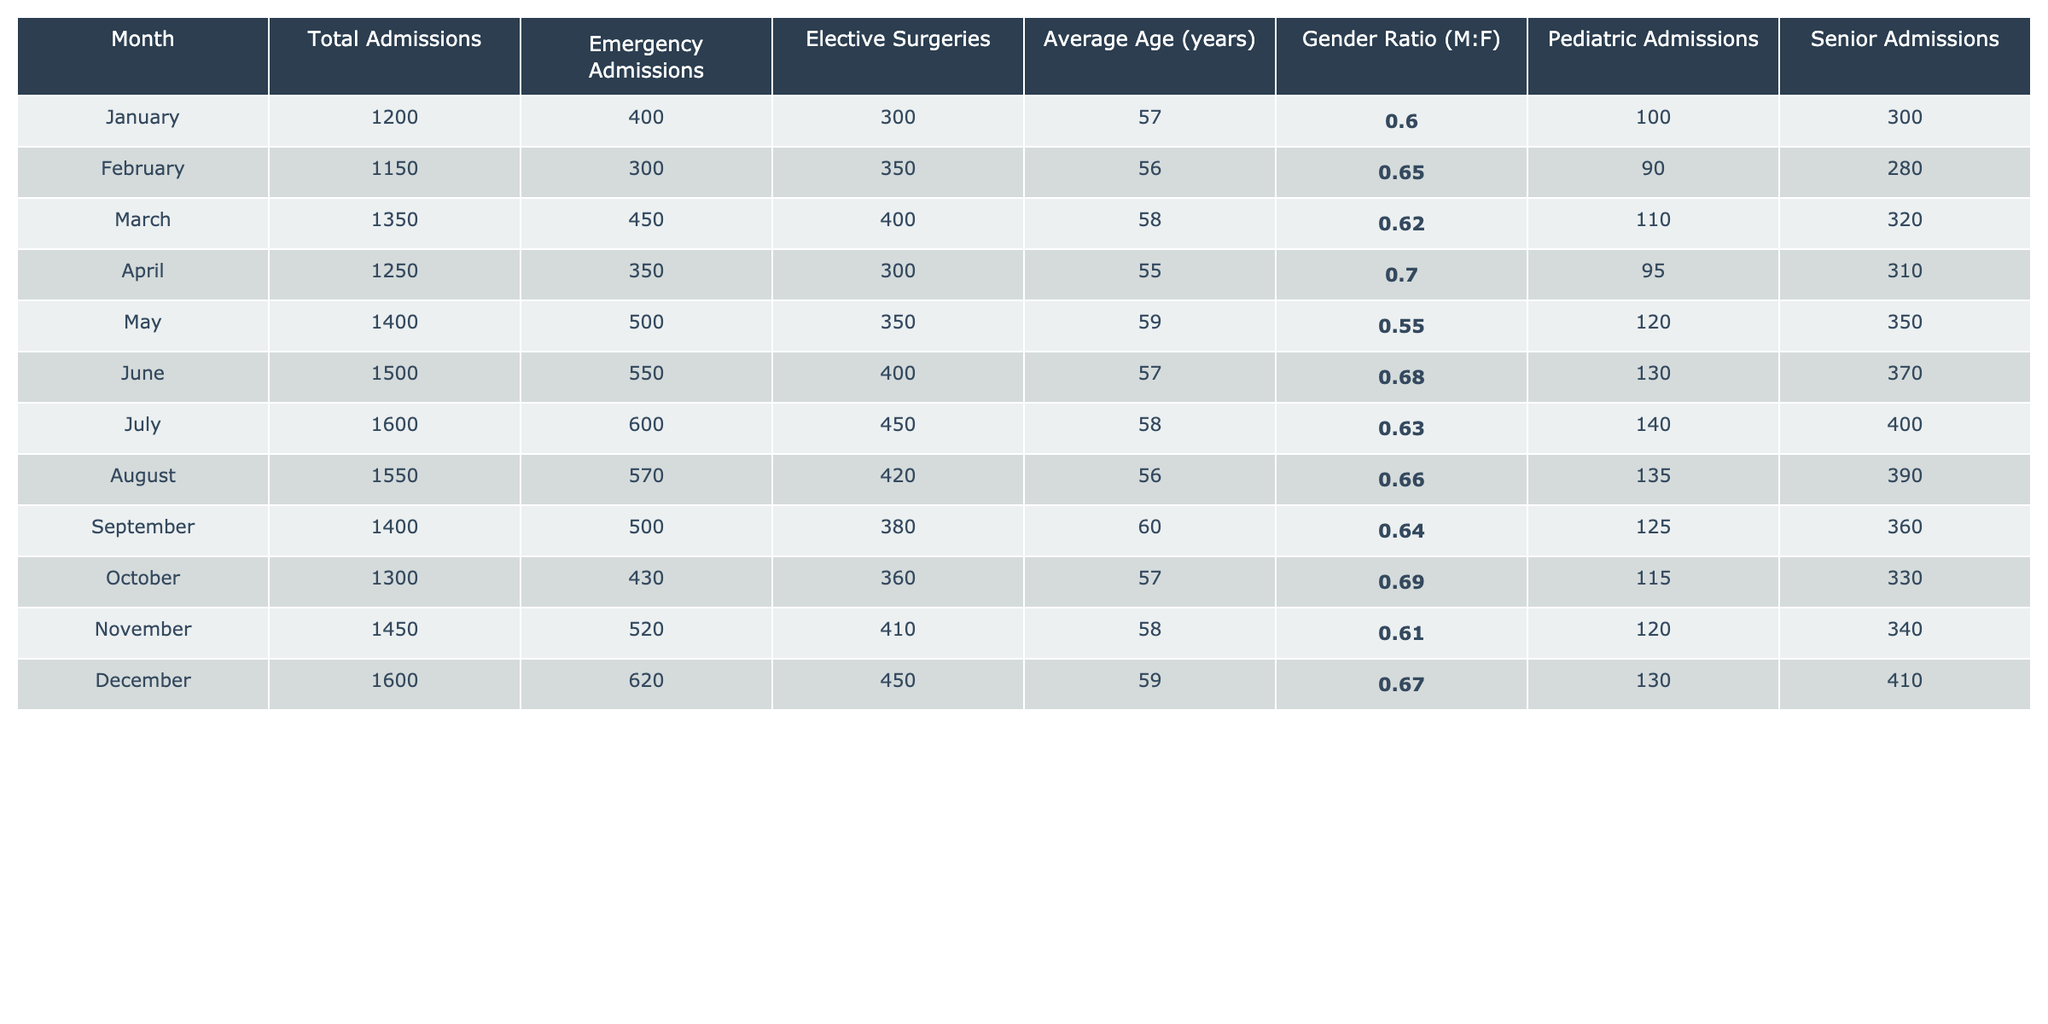What's the total number of admissions in December? The table lists the total admissions for December as 1600.
Answer: 1600 What is the average age of patients admitted in April? The average age for patients in April, as per the table, is 55 years.
Answer: 55 In which month were the most emergency admissions recorded? Upon reviewing the emergency admissions, July has the highest count with 600 admissions.
Answer: July Is the average age of senior admissions higher in August than in November? In August, there are 390 senior admissions and in November there are 340. Since the average age isn't directly noted, we conclude that senior admissions in November are higher, but this does not address average age.
Answer: No What is the gender ratio for March? The gender ratio for March is presented as 0.62, which is bolded in the table.
Answer: 0.62 How many more total admissions were recorded in July compared to January? Total admissions in July is 1600, and in January it is 1200. The difference is calculated as 1600 - 1200 = 400.
Answer: 400 Was there an increase or decrease in total admissions from February to March? From February (1150) to March (1350), there is an increase of 200 total admissions.
Answer: Increase Which month had the lowest average age of patients admitted? By reviewing the average ages listed, April had the lowest average age at 55 years.
Answer: April Calculate the total number of elective surgeries performed from June to December. The elective surgeries from June (400), July (450), August (420), September (380), October (360), November (410), and December (450) total to 400 + 450 + 420 + 380 + 360 + 410 + 450 = 2870.
Answer: 2870 Is the gender ratio in October higher than in February? The gender ratio for October is 0.69 and for February it is 0.65, so October has a higher ratio.
Answer: Yes What is the ratio of pediatric admissions to senior admissions in May? The pediatric admissions in May are 120, and senior admissions are 350. The ratio is calculated as 120:350, or simplified, approximately 0.34.
Answer: 0.34 